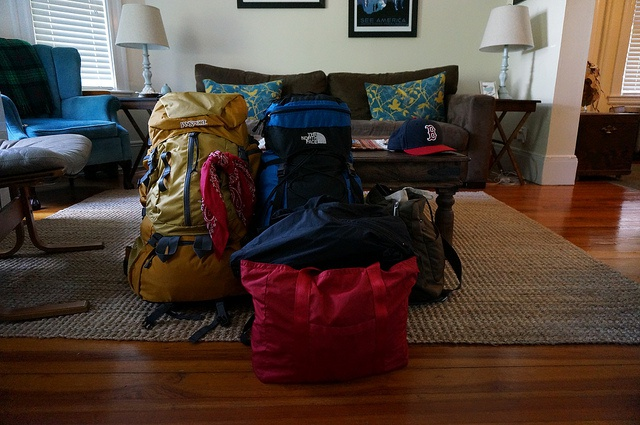Describe the objects in this image and their specific colors. I can see handbag in gray, black, maroon, navy, and brown tones, backpack in gray, black, maroon, navy, and brown tones, backpack in gray, black, maroon, olive, and tan tones, couch in gray, black, blue, and darkgray tones, and backpack in gray, black, navy, and blue tones in this image. 